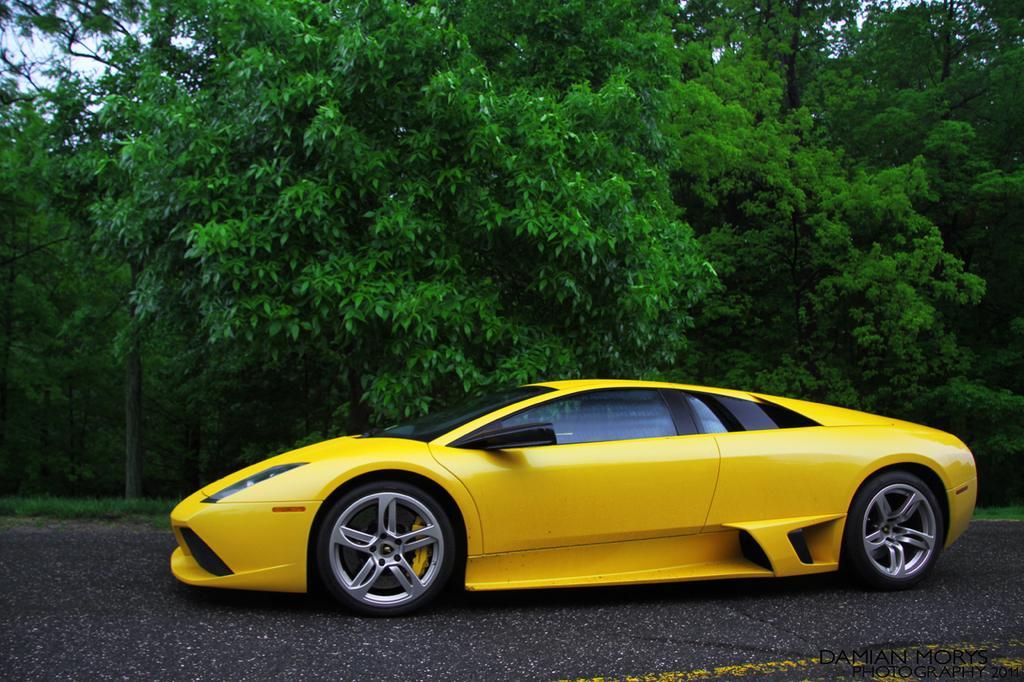Can you describe this image briefly? In the center of the image there is a car which is in yellow color on the road. In the background there are trees and sky. 